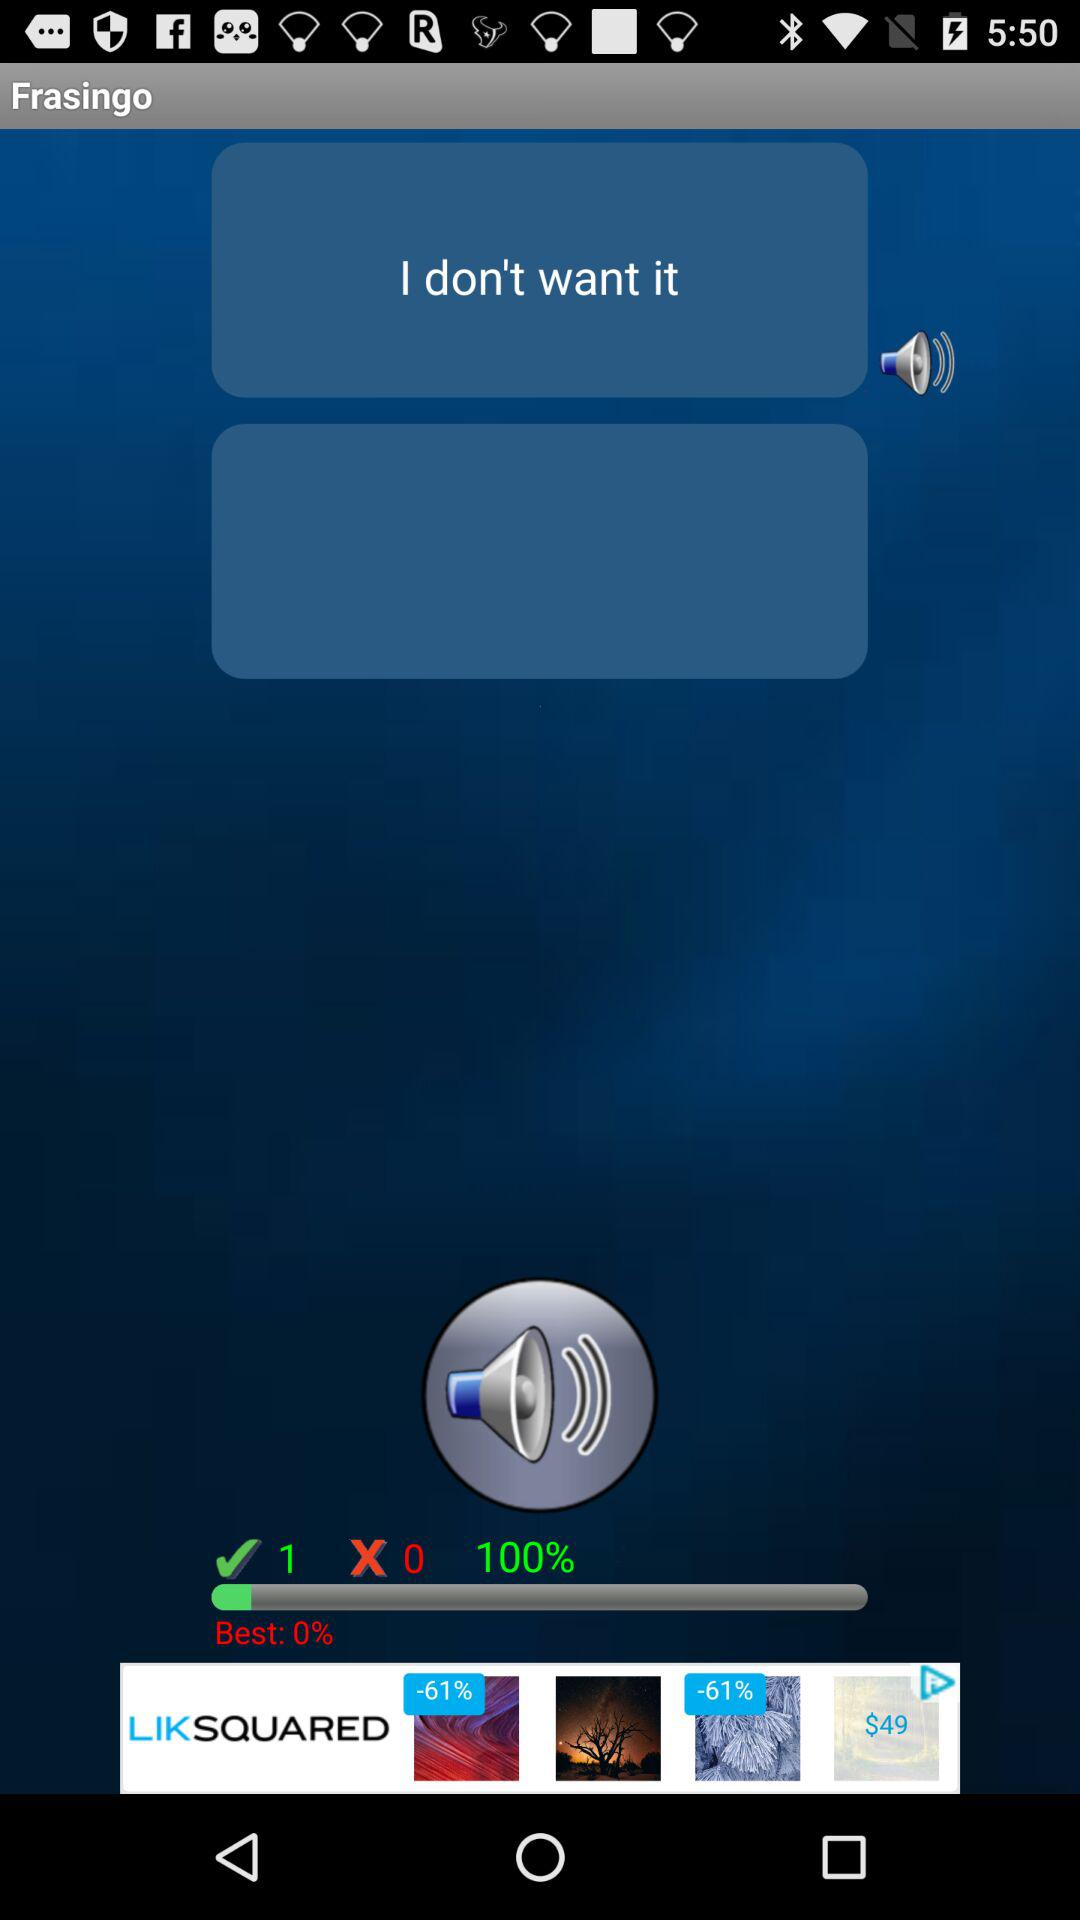How many more checkmarks are there than x's on the screen?
Answer the question using a single word or phrase. 1 